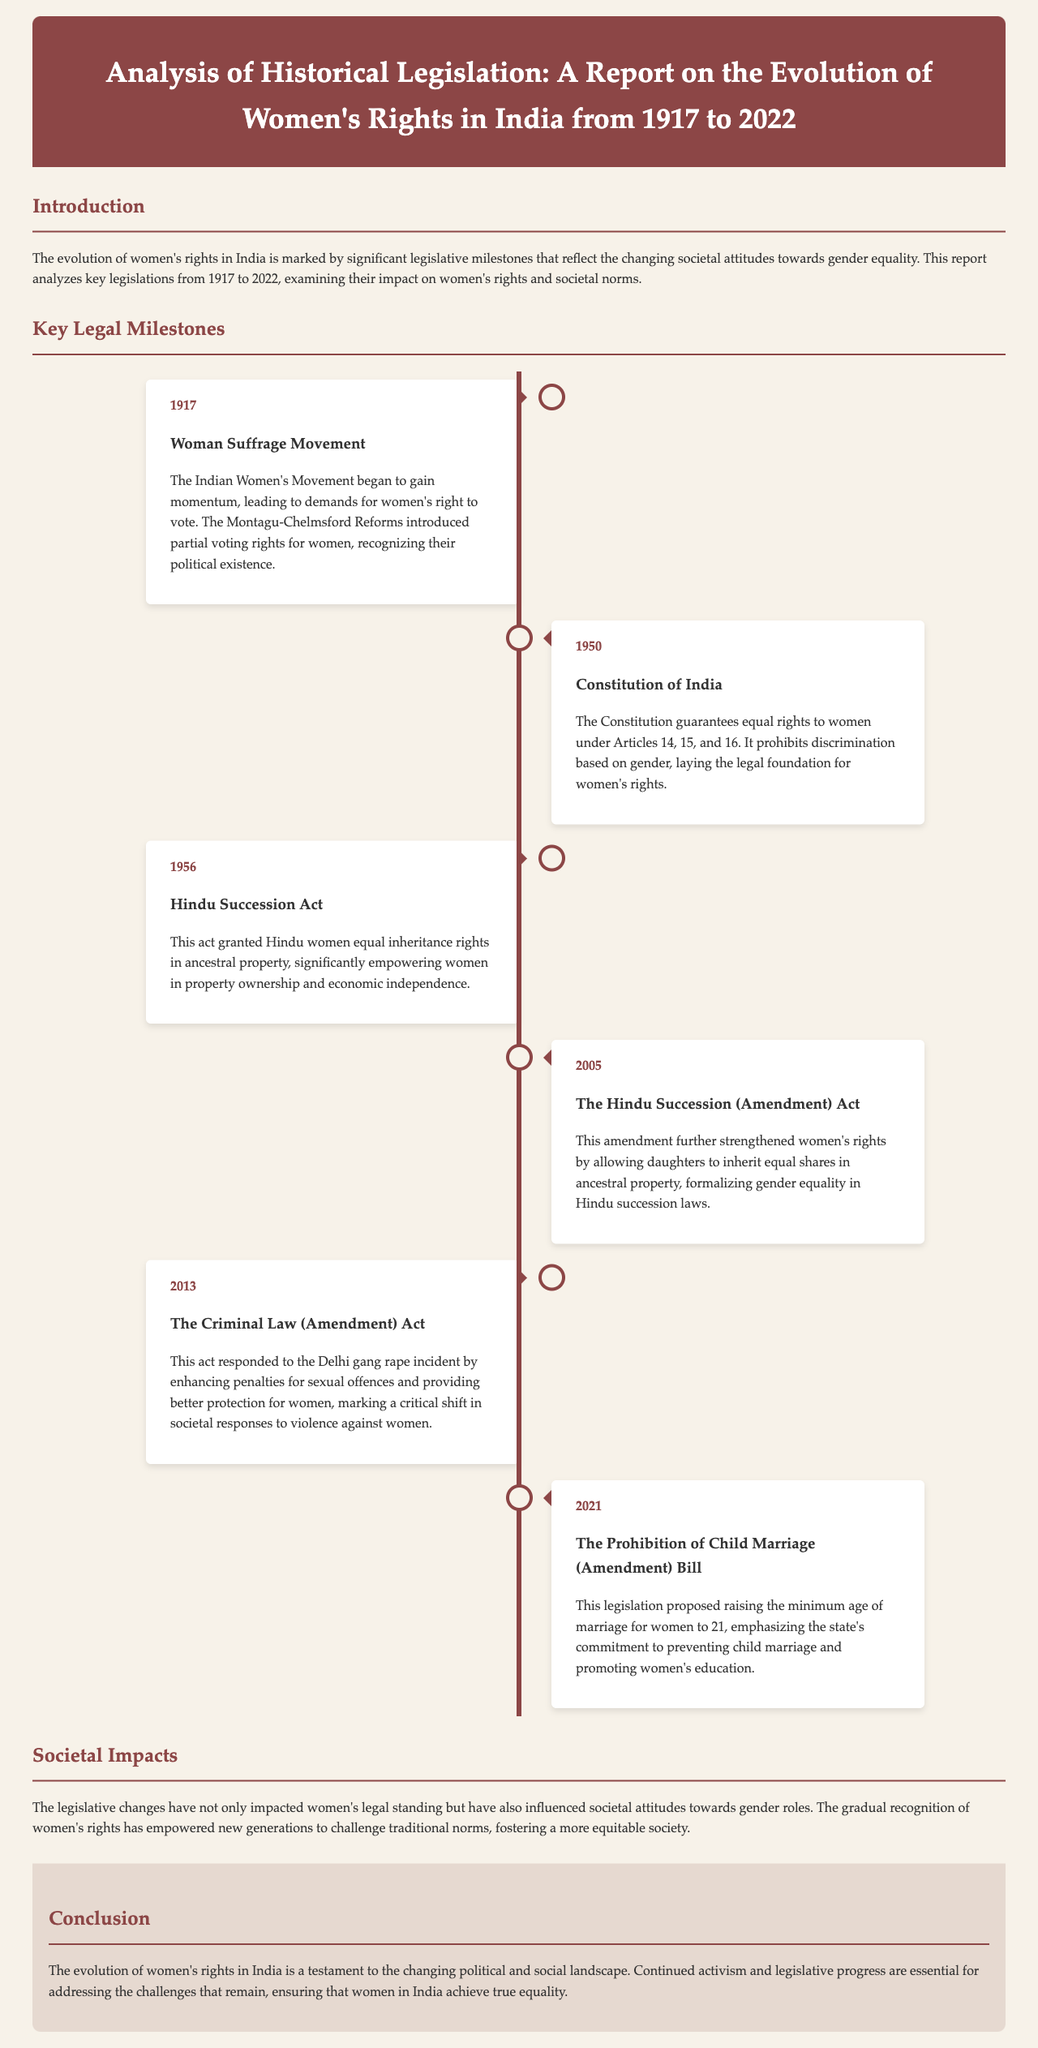What year did the Woman Suffrage Movement gain momentum? The Woman Suffrage Movement gained momentum in 1917, marking the beginning of demands for women's right to vote.
Answer: 1917 What significant legal change occurred in 1950? The Constitution of India was enacted in 1950, guaranteeing equal rights to women under Articles 14, 15, and 16.
Answer: Constitution of India What act was introduced in 1956 that impacted women's property rights? The Hindu Succession Act was introduced in 1956, granting Hindu women equal inheritance rights in ancestral property.
Answer: Hindu Succession Act Which amendment in 2005 formalized gender equality in Hindu succession laws? The Hindu Succession (Amendment) Act in 2005 allowed daughters to inherit equal shares in ancestral property.
Answer: Hindu Succession (Amendment) Act What legislative response occurred in 2013 after a major incident in Delhi? The Criminal Law (Amendment) Act was introduced in 2013 enhancing penalties for sexual offences and protecting women.
Answer: Criminal Law (Amendment) Act What did the 2021 Bill propose regarding the minimum age of marriage? The Prohibition of Child Marriage (Amendment) Bill proposed raising the minimum age of marriage for women to 21.
Answer: 21 What is the main focus of the societal impacts section? The societal impacts section discusses how legislative changes have influenced attitudes towards gender roles and women's empowerment.
Answer: Attitudes towards gender roles What key themes are addressed in the conclusion of the report? The conclusion addresses the evolution of women's rights and the importance of continued activism and legislative progress.
Answer: Continued activism and legislative progress 